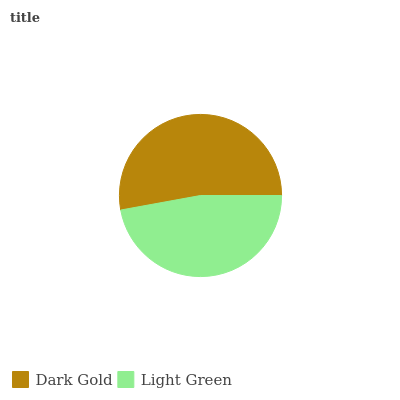Is Light Green the minimum?
Answer yes or no. Yes. Is Dark Gold the maximum?
Answer yes or no. Yes. Is Light Green the maximum?
Answer yes or no. No. Is Dark Gold greater than Light Green?
Answer yes or no. Yes. Is Light Green less than Dark Gold?
Answer yes or no. Yes. Is Light Green greater than Dark Gold?
Answer yes or no. No. Is Dark Gold less than Light Green?
Answer yes or no. No. Is Dark Gold the high median?
Answer yes or no. Yes. Is Light Green the low median?
Answer yes or no. Yes. Is Light Green the high median?
Answer yes or no. No. Is Dark Gold the low median?
Answer yes or no. No. 